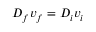Convert formula to latex. <formula><loc_0><loc_0><loc_500><loc_500>D _ { f } v _ { f } = D _ { i } v _ { i }</formula> 